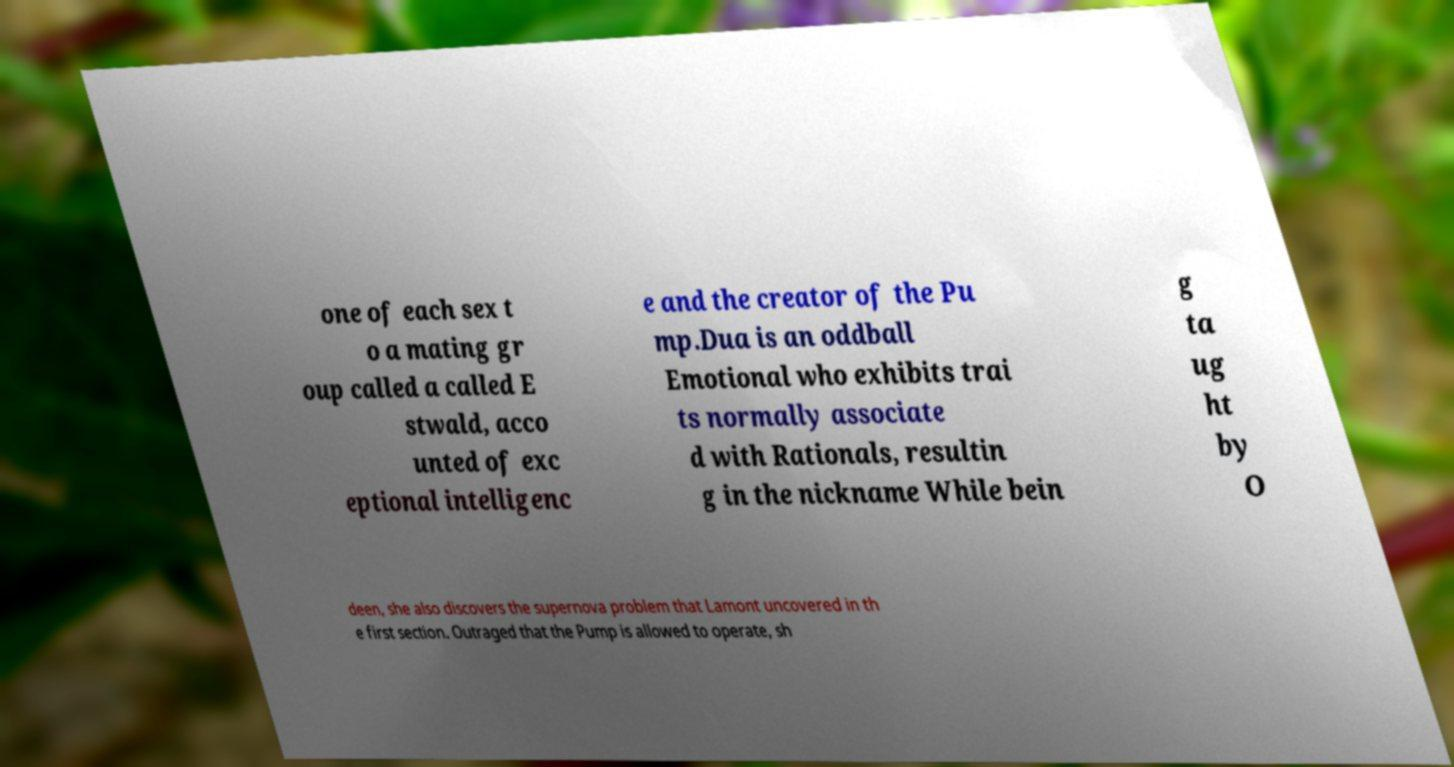What messages or text are displayed in this image? I need them in a readable, typed format. one of each sex t o a mating gr oup called a called E stwald, acco unted of exc eptional intelligenc e and the creator of the Pu mp.Dua is an oddball Emotional who exhibits trai ts normally associate d with Rationals, resultin g in the nickname While bein g ta ug ht by O deen, she also discovers the supernova problem that Lamont uncovered in th e first section. Outraged that the Pump is allowed to operate, sh 